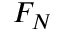<formula> <loc_0><loc_0><loc_500><loc_500>F _ { N }</formula> 